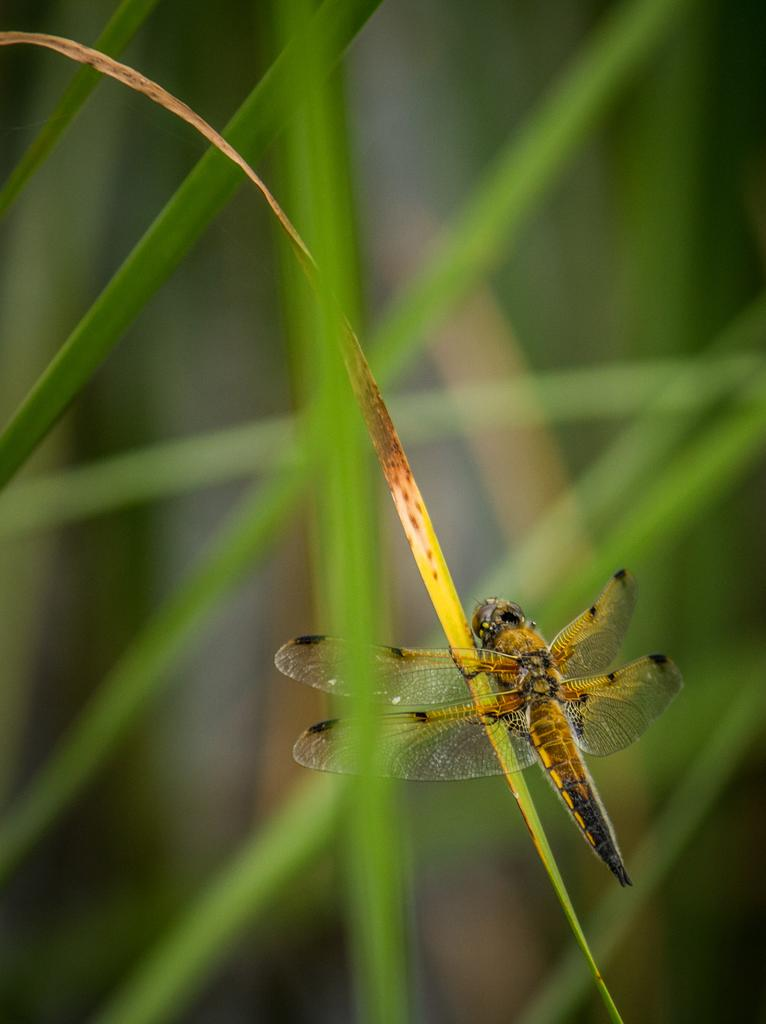What insect can be seen in the image? There is a dragonfly in the image. Where is the dragonfly located? The dragonfly is on the grass. What type of vegetation is visible in the image? There is grass visible in the image. Can you describe the background of the image? The background of the image is blurry. What sound does the dragonfly make in the image? Dragonflies do not make sounds that can be heard by humans, so there is no sound to describe in the image. 